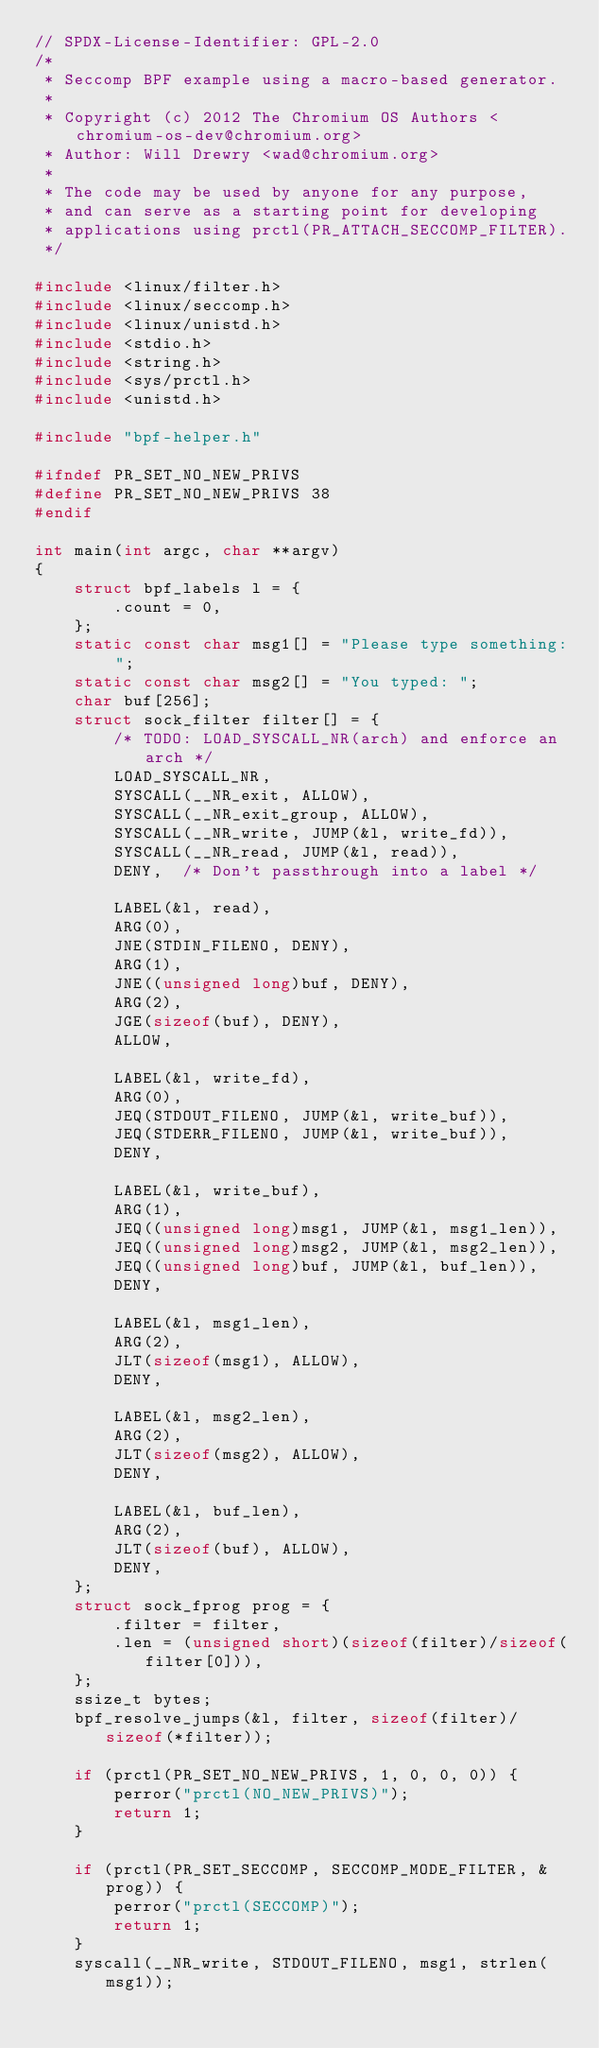<code> <loc_0><loc_0><loc_500><loc_500><_C_>// SPDX-License-Identifier: GPL-2.0
/*
 * Seccomp BPF example using a macro-based generator.
 *
 * Copyright (c) 2012 The Chromium OS Authors <chromium-os-dev@chromium.org>
 * Author: Will Drewry <wad@chromium.org>
 *
 * The code may be used by anyone for any purpose,
 * and can serve as a starting point for developing
 * applications using prctl(PR_ATTACH_SECCOMP_FILTER).
 */

#include <linux/filter.h>
#include <linux/seccomp.h>
#include <linux/unistd.h>
#include <stdio.h>
#include <string.h>
#include <sys/prctl.h>
#include <unistd.h>

#include "bpf-helper.h"

#ifndef PR_SET_NO_NEW_PRIVS
#define PR_SET_NO_NEW_PRIVS 38
#endif

int main(int argc, char **argv)
{
	struct bpf_labels l = {
		.count = 0,
	};
	static const char msg1[] = "Please type something: ";
	static const char msg2[] = "You typed: ";
	char buf[256];
	struct sock_filter filter[] = {
		/* TODO: LOAD_SYSCALL_NR(arch) and enforce an arch */
		LOAD_SYSCALL_NR,
		SYSCALL(__NR_exit, ALLOW),
		SYSCALL(__NR_exit_group, ALLOW),
		SYSCALL(__NR_write, JUMP(&l, write_fd)),
		SYSCALL(__NR_read, JUMP(&l, read)),
		DENY,  /* Don't passthrough into a label */

		LABEL(&l, read),
		ARG(0),
		JNE(STDIN_FILENO, DENY),
		ARG(1),
		JNE((unsigned long)buf, DENY),
		ARG(2),
		JGE(sizeof(buf), DENY),
		ALLOW,

		LABEL(&l, write_fd),
		ARG(0),
		JEQ(STDOUT_FILENO, JUMP(&l, write_buf)),
		JEQ(STDERR_FILENO, JUMP(&l, write_buf)),
		DENY,

		LABEL(&l, write_buf),
		ARG(1),
		JEQ((unsigned long)msg1, JUMP(&l, msg1_len)),
		JEQ((unsigned long)msg2, JUMP(&l, msg2_len)),
		JEQ((unsigned long)buf, JUMP(&l, buf_len)),
		DENY,

		LABEL(&l, msg1_len),
		ARG(2),
		JLT(sizeof(msg1), ALLOW),
		DENY,

		LABEL(&l, msg2_len),
		ARG(2),
		JLT(sizeof(msg2), ALLOW),
		DENY,

		LABEL(&l, buf_len),
		ARG(2),
		JLT(sizeof(buf), ALLOW),
		DENY,
	};
	struct sock_fprog prog = {
		.filter = filter,
		.len = (unsigned short)(sizeof(filter)/sizeof(filter[0])),
	};
	ssize_t bytes;
	bpf_resolve_jumps(&l, filter, sizeof(filter)/sizeof(*filter));

	if (prctl(PR_SET_NO_NEW_PRIVS, 1, 0, 0, 0)) {
		perror("prctl(NO_NEW_PRIVS)");
		return 1;
	}

	if (prctl(PR_SET_SECCOMP, SECCOMP_MODE_FILTER, &prog)) {
		perror("prctl(SECCOMP)");
		return 1;
	}
	syscall(__NR_write, STDOUT_FILENO, msg1, strlen(msg1));</code> 